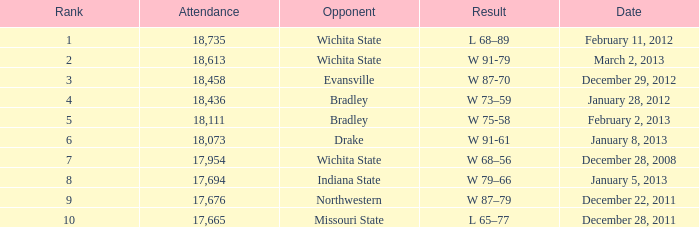In a match against northwestern with an attendance of fewer than 18,073, what is the corresponding rank? 9.0. 